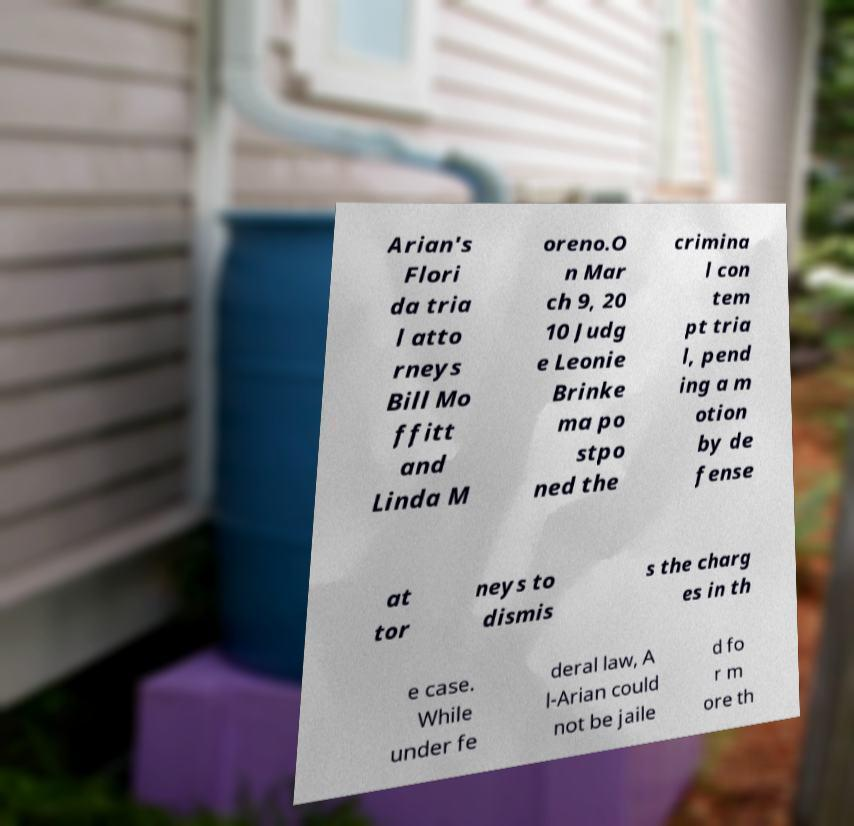Can you accurately transcribe the text from the provided image for me? Arian's Flori da tria l atto rneys Bill Mo ffitt and Linda M oreno.O n Mar ch 9, 20 10 Judg e Leonie Brinke ma po stpo ned the crimina l con tem pt tria l, pend ing a m otion by de fense at tor neys to dismis s the charg es in th e case. While under fe deral law, A l-Arian could not be jaile d fo r m ore th 